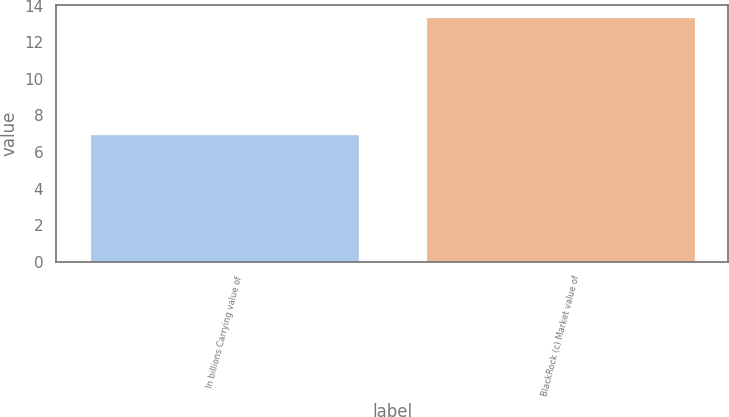<chart> <loc_0><loc_0><loc_500><loc_500><bar_chart><fcel>In billions Carrying value of<fcel>BlackRock (c) Market value of<nl><fcel>7<fcel>13.4<nl></chart> 